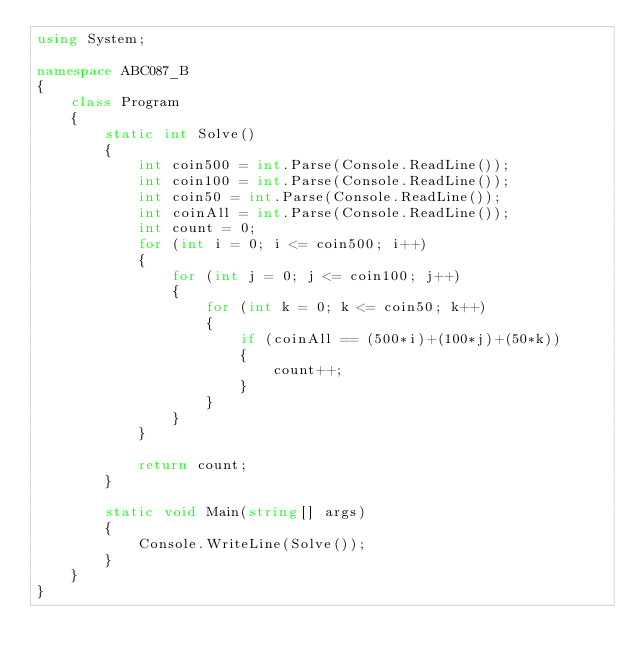<code> <loc_0><loc_0><loc_500><loc_500><_C#_>using System;

namespace ABC087_B
{
    class Program
    {
        static int Solve()
        {
            int coin500 = int.Parse(Console.ReadLine());
            int coin100 = int.Parse(Console.ReadLine());
            int coin50 = int.Parse(Console.ReadLine());
            int coinAll = int.Parse(Console.ReadLine());
            int count = 0;
            for (int i = 0; i <= coin500; i++)
            {
                for (int j = 0; j <= coin100; j++)
                {
                    for (int k = 0; k <= coin50; k++)
                    {
                        if (coinAll == (500*i)+(100*j)+(50*k))
                        {
                            count++;
                        }
                    }
                }
            }

            return count;
        }

        static void Main(string[] args)
        {
            Console.WriteLine(Solve());
        }
    }
}
</code> 